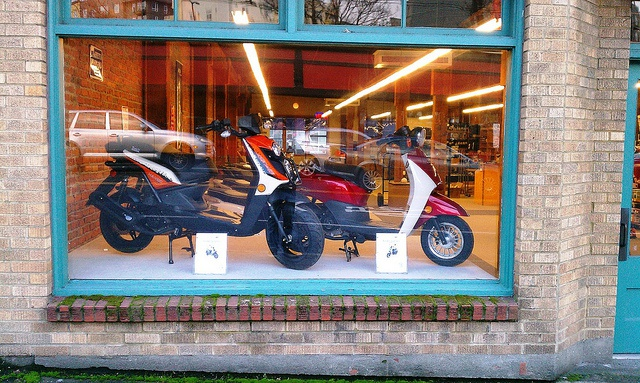Describe the objects in this image and their specific colors. I can see motorcycle in tan, black, navy, darkblue, and gray tones, motorcycle in tan, navy, black, maroon, and lavender tones, car in tan, lightgray, salmon, lightpink, and black tones, car in tan, maroon, gray, and black tones, and car in tan, lavender, brown, darkgray, and maroon tones in this image. 